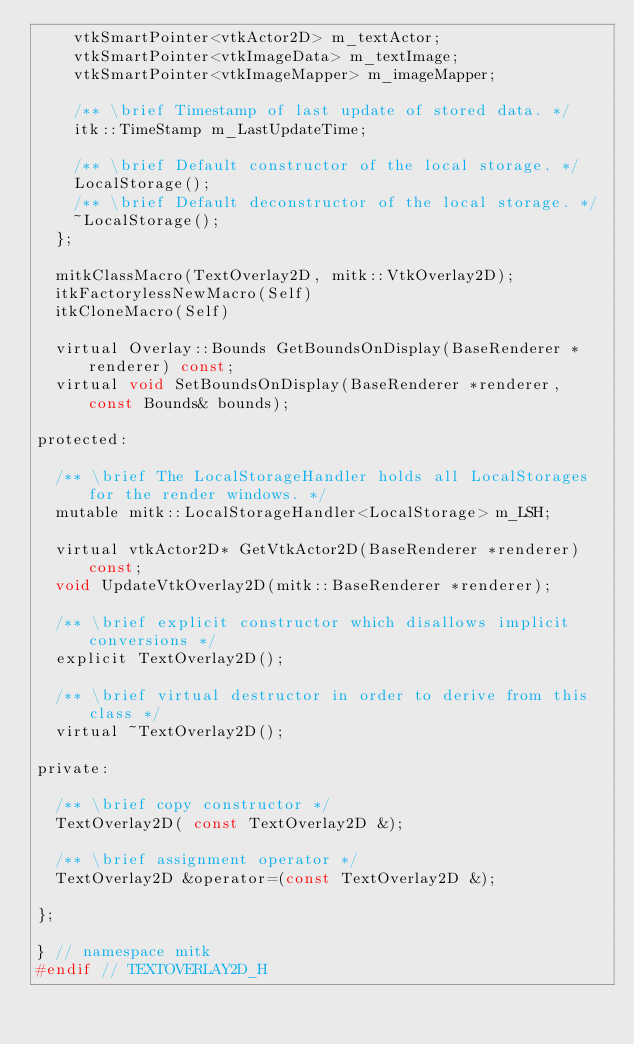<code> <loc_0><loc_0><loc_500><loc_500><_C_>    vtkSmartPointer<vtkActor2D> m_textActor;
    vtkSmartPointer<vtkImageData> m_textImage;
    vtkSmartPointer<vtkImageMapper> m_imageMapper;

    /** \brief Timestamp of last update of stored data. */
    itk::TimeStamp m_LastUpdateTime;

    /** \brief Default constructor of the local storage. */
    LocalStorage();
    /** \brief Default deconstructor of the local storage. */
    ~LocalStorage();
  };

  mitkClassMacro(TextOverlay2D, mitk::VtkOverlay2D);
  itkFactorylessNewMacro(Self)
  itkCloneMacro(Self)

  virtual Overlay::Bounds GetBoundsOnDisplay(BaseRenderer *renderer) const;
  virtual void SetBoundsOnDisplay(BaseRenderer *renderer, const Bounds& bounds);

protected:

  /** \brief The LocalStorageHandler holds all LocalStorages for the render windows. */
  mutable mitk::LocalStorageHandler<LocalStorage> m_LSH;

  virtual vtkActor2D* GetVtkActor2D(BaseRenderer *renderer) const;
  void UpdateVtkOverlay2D(mitk::BaseRenderer *renderer);

  /** \brief explicit constructor which disallows implicit conversions */
  explicit TextOverlay2D();

  /** \brief virtual destructor in order to derive from this class */
  virtual ~TextOverlay2D();

private:

  /** \brief copy constructor */
  TextOverlay2D( const TextOverlay2D &);

  /** \brief assignment operator */
  TextOverlay2D &operator=(const TextOverlay2D &);

};

} // namespace mitk
#endif // TEXTOVERLAY2D_H


</code> 